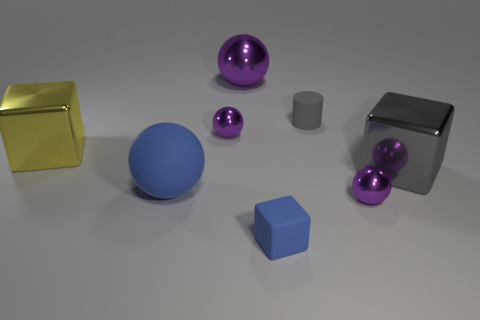What shape is the large gray object that is the same material as the large yellow cube?
Keep it short and to the point. Cube. There is a tiny shiny object behind the big yellow thing; are there any gray cylinders to the left of it?
Your answer should be very brief. No. What size is the gray shiny cube?
Make the answer very short. Large. What number of objects are either gray cylinders or small brown shiny blocks?
Offer a terse response. 1. Are the large block left of the large purple metallic thing and the tiny object that is to the left of the big purple metallic ball made of the same material?
Offer a very short reply. Yes. There is a large sphere that is made of the same material as the yellow cube; what color is it?
Offer a very short reply. Purple. What number of blue spheres have the same size as the yellow metal object?
Provide a succinct answer. 1. What number of other things are the same color as the matte ball?
Provide a short and direct response. 1. Are there any other things that are the same size as the gray cylinder?
Provide a short and direct response. Yes. Do the rubber thing that is left of the big purple metallic ball and the small metal object behind the yellow thing have the same shape?
Ensure brevity in your answer.  Yes. 